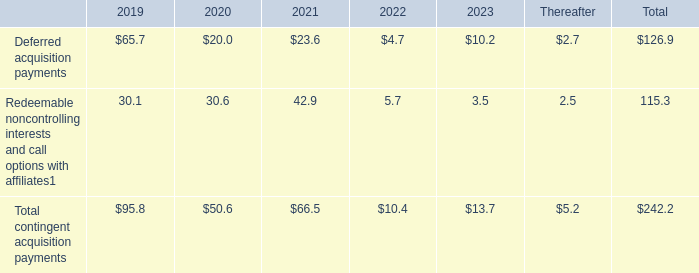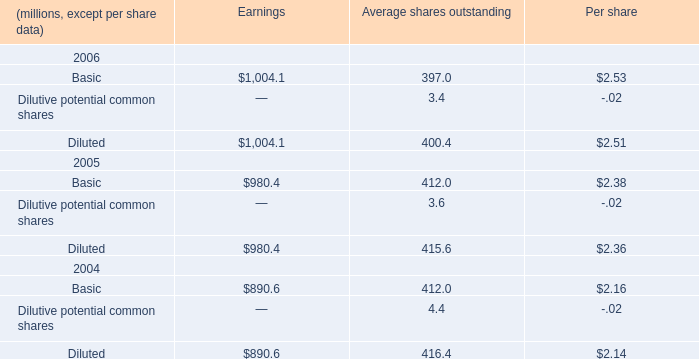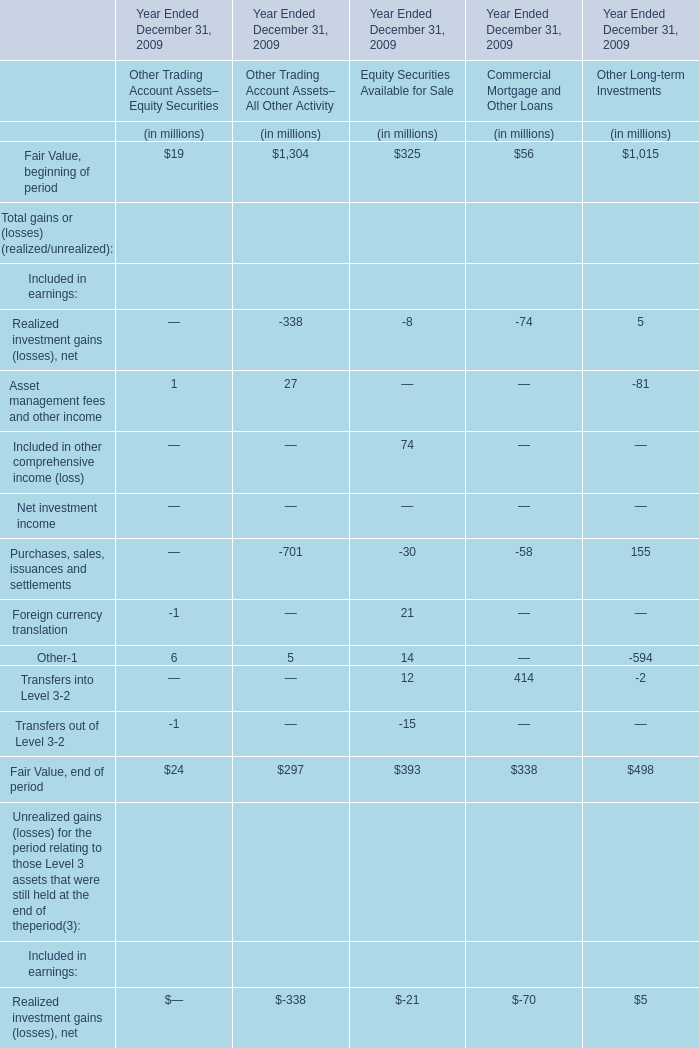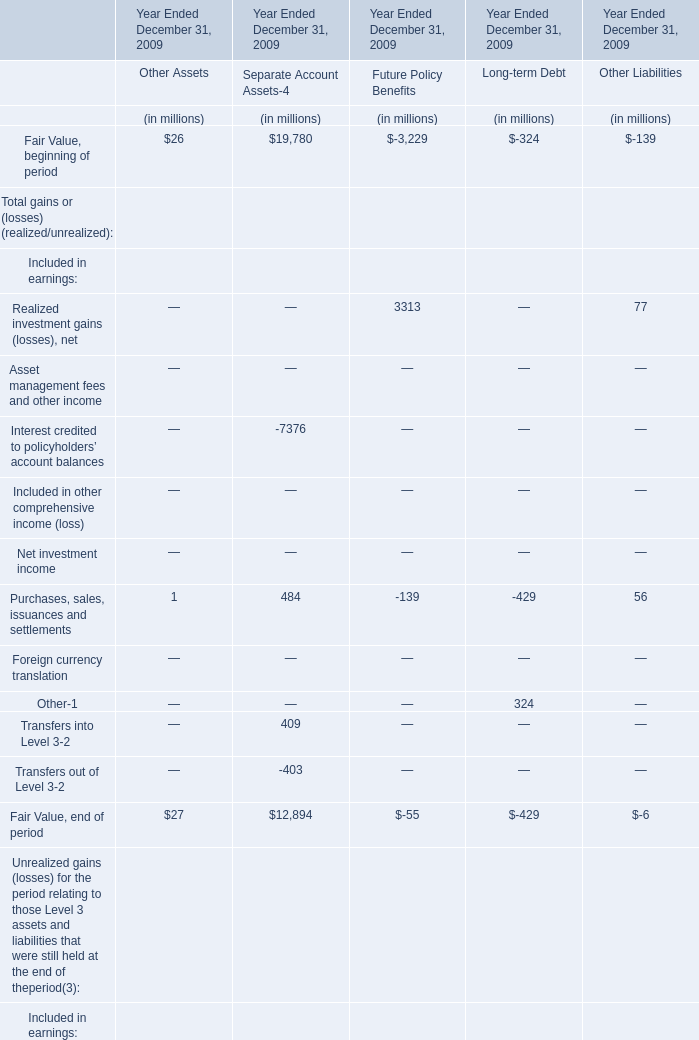what percentage of the total deferred acquisition payments were made in 2019? 
Computations: ((65.7 / 126.9) * 100)
Answer: 51.77305. 